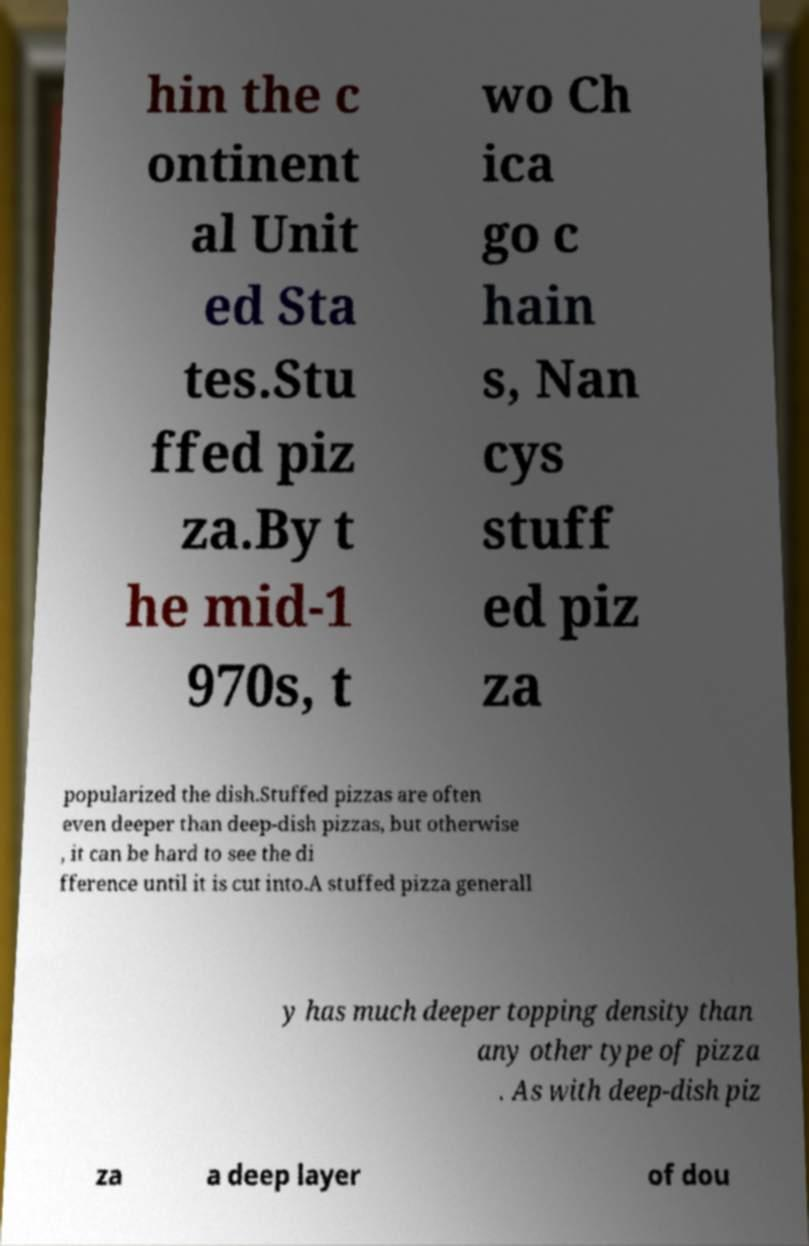There's text embedded in this image that I need extracted. Can you transcribe it verbatim? hin the c ontinent al Unit ed Sta tes.Stu ffed piz za.By t he mid-1 970s, t wo Ch ica go c hain s, Nan cys stuff ed piz za popularized the dish.Stuffed pizzas are often even deeper than deep-dish pizzas, but otherwise , it can be hard to see the di fference until it is cut into.A stuffed pizza generall y has much deeper topping density than any other type of pizza . As with deep-dish piz za a deep layer of dou 